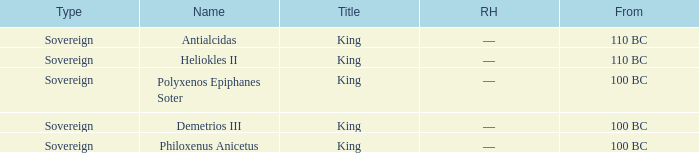Could you parse the entire table as a dict? {'header': ['Type', 'Name', 'Title', 'RH', 'From'], 'rows': [['Sovereign', 'Antialcidas', 'King', '—', '110 BC'], ['Sovereign', 'Heliokles II', 'King', '—', '110 BC'], ['Sovereign', 'Polyxenos Epiphanes Soter', 'King', '—', '100 BC'], ['Sovereign', 'Demetrios III', 'King', '—', '100 BC'], ['Sovereign', 'Philoxenus Anicetus', 'King', '—', '100 BC']]} Which royal house corresponds to Polyxenos Epiphanes Soter? —. 